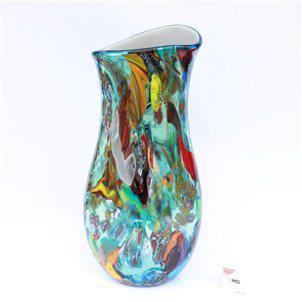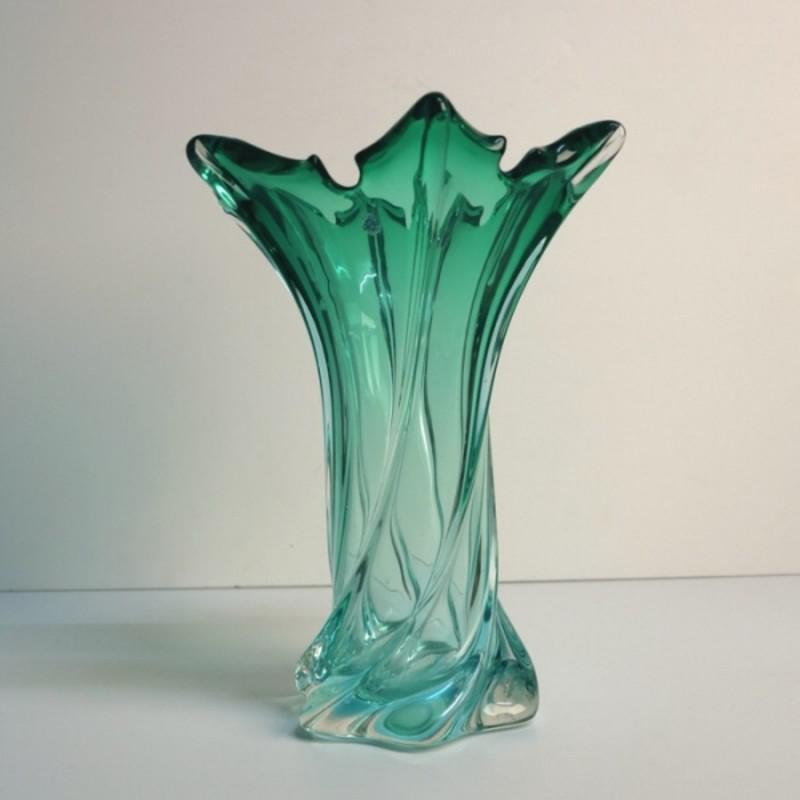The first image is the image on the left, the second image is the image on the right. Analyze the images presented: Is the assertion "The vase in the right image is bluish-green, with no other bright colors on it." valid? Answer yes or no. Yes. The first image is the image on the left, the second image is the image on the right. For the images shown, is this caption "The vase on the right is a green color." true? Answer yes or no. Yes. 